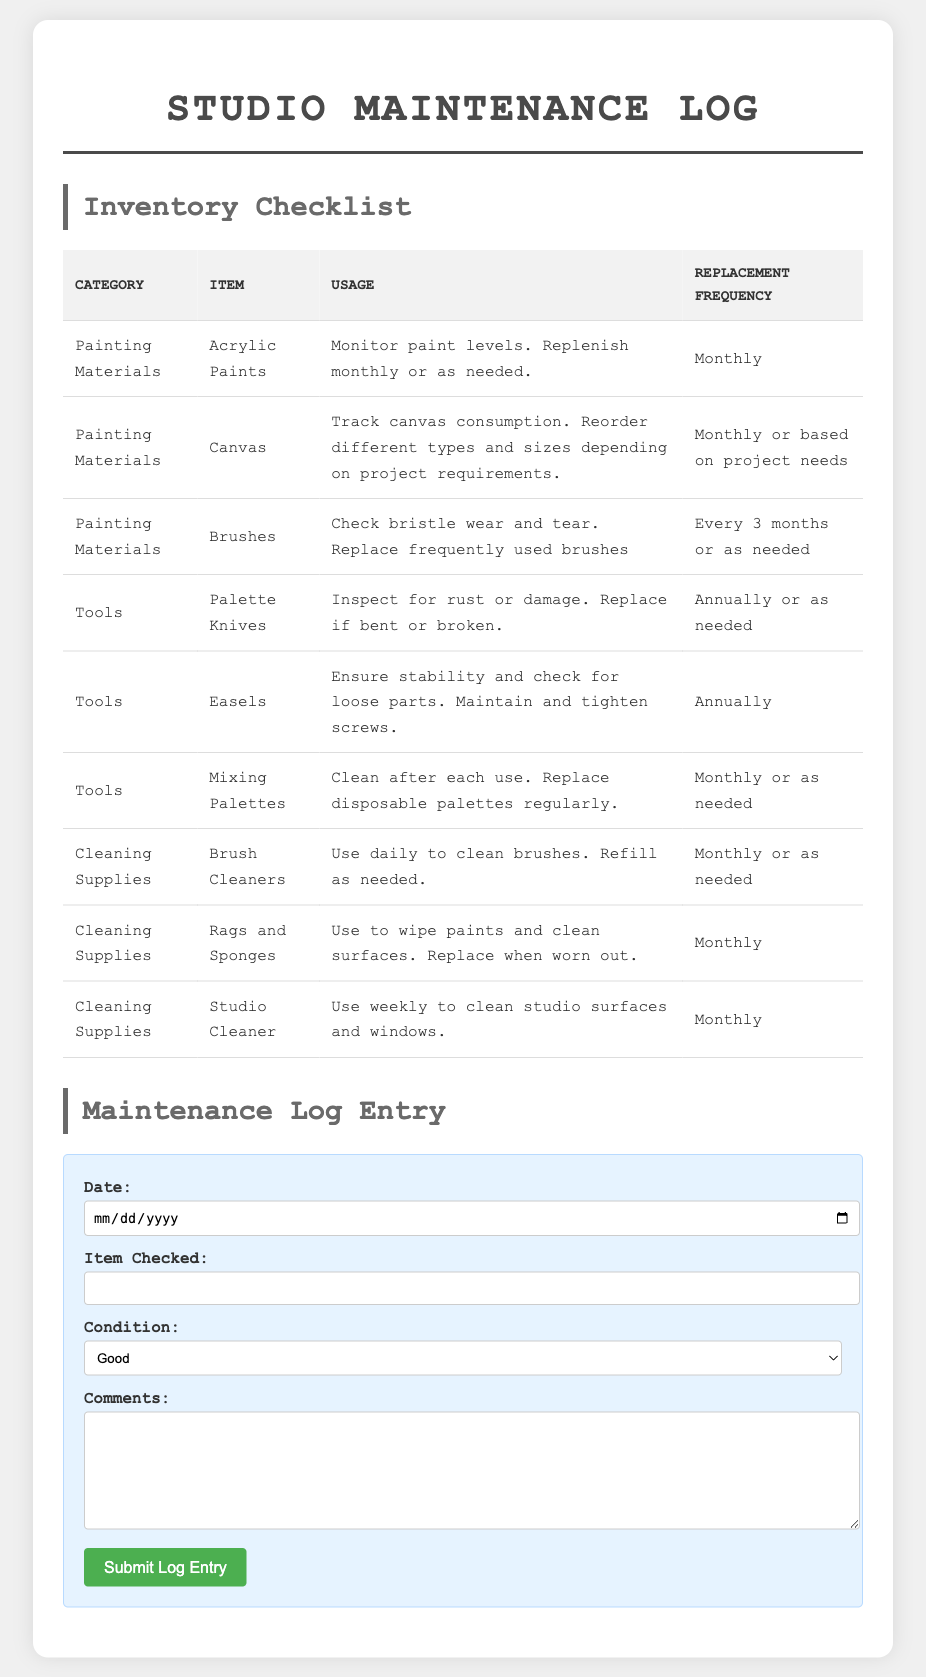What is the monthly replacement frequency for acrylic paints? Acrylic paints need to be replenished monthly or as needed, as indicated in the inventory checklist.
Answer: Monthly How often should brushes be replaced? The inventory specifies that frequently used brushes should be replaced every 3 months or as needed.
Answer: Every 3 months What condition options are available in the maintenance log entry? The options available for the condition in the log entry include Good, Need Replacement, and Replaced.
Answer: Good, Need Replacement, Replaced What item should be cleaned after each use? The inventory states that mixing palettes should be cleaned after each use.
Answer: Mixing Palettes Which cleaning supply is used weekly? According to the inventory checklist, the studio cleaner is used weekly to clean studio surfaces and windows.
Answer: Studio Cleaner How many painting materials are listed in the inventory? The document lists three painting materials: acrylic paints, canvas, and brushes. Therefore, the total is three.
Answer: Three What is the usage guideline for canvas? The usage guideline for canvas states to track canvas consumption and reorder based on project requirements.
Answer: Track canvas consumption What is the purpose of inspecting palette knives? Palette knives should be inspected for rust or damage and replaced if bent or broken, as per the inventory checklist.
Answer: Inspect for rust or damage 